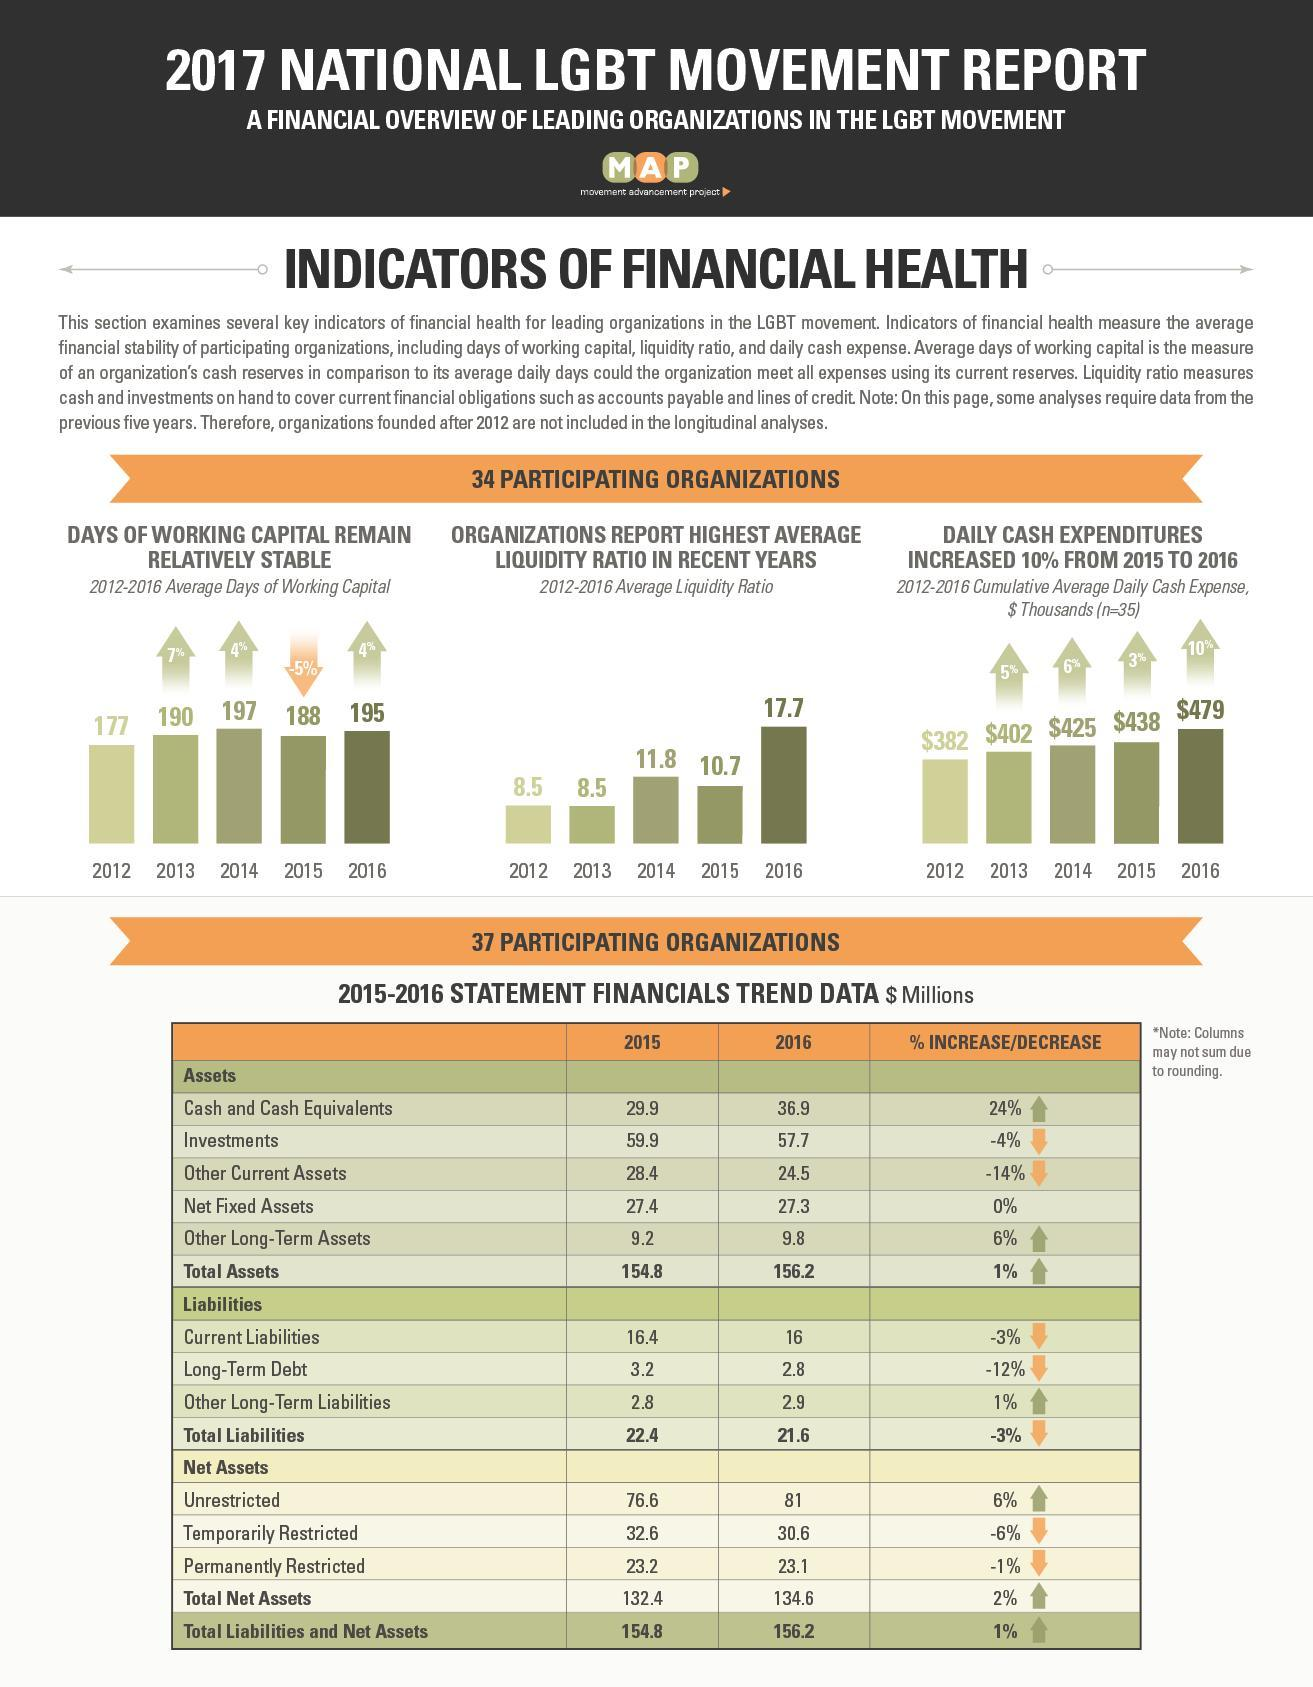What is the increase in total assets from 2015 to 2016?
Answer the question with a short phrase. $1.4 million What is the combined cash and cash equivalents in 2015 and 2016? $66.8 million What is the percentage of increase in total liabilities and net assets from 2015 to 2016? 1% What is the increase in total net assets from 2015 to 2016? $2.2 million What is the total investments in 2015 and 2016? $117.6 million What is the decrease in total liabilities from 2015 to 2016? $.8 million What is the total unrestricted net assets in 2015 and 2016? 157.6 million What is the total liabilities and net assets in 2015 and 2016? $311 million What is the total temporarily restricted and permanently restricted net assets in 2016? $53.7 million What is the total net fixed assets in 2015 and 2016? $54.7 million What is the combined current liabilities in 2015 and 2016? $32.4 million What is the total temporarily restricted and permanently restricted net assets in 2015? $55.8 million 